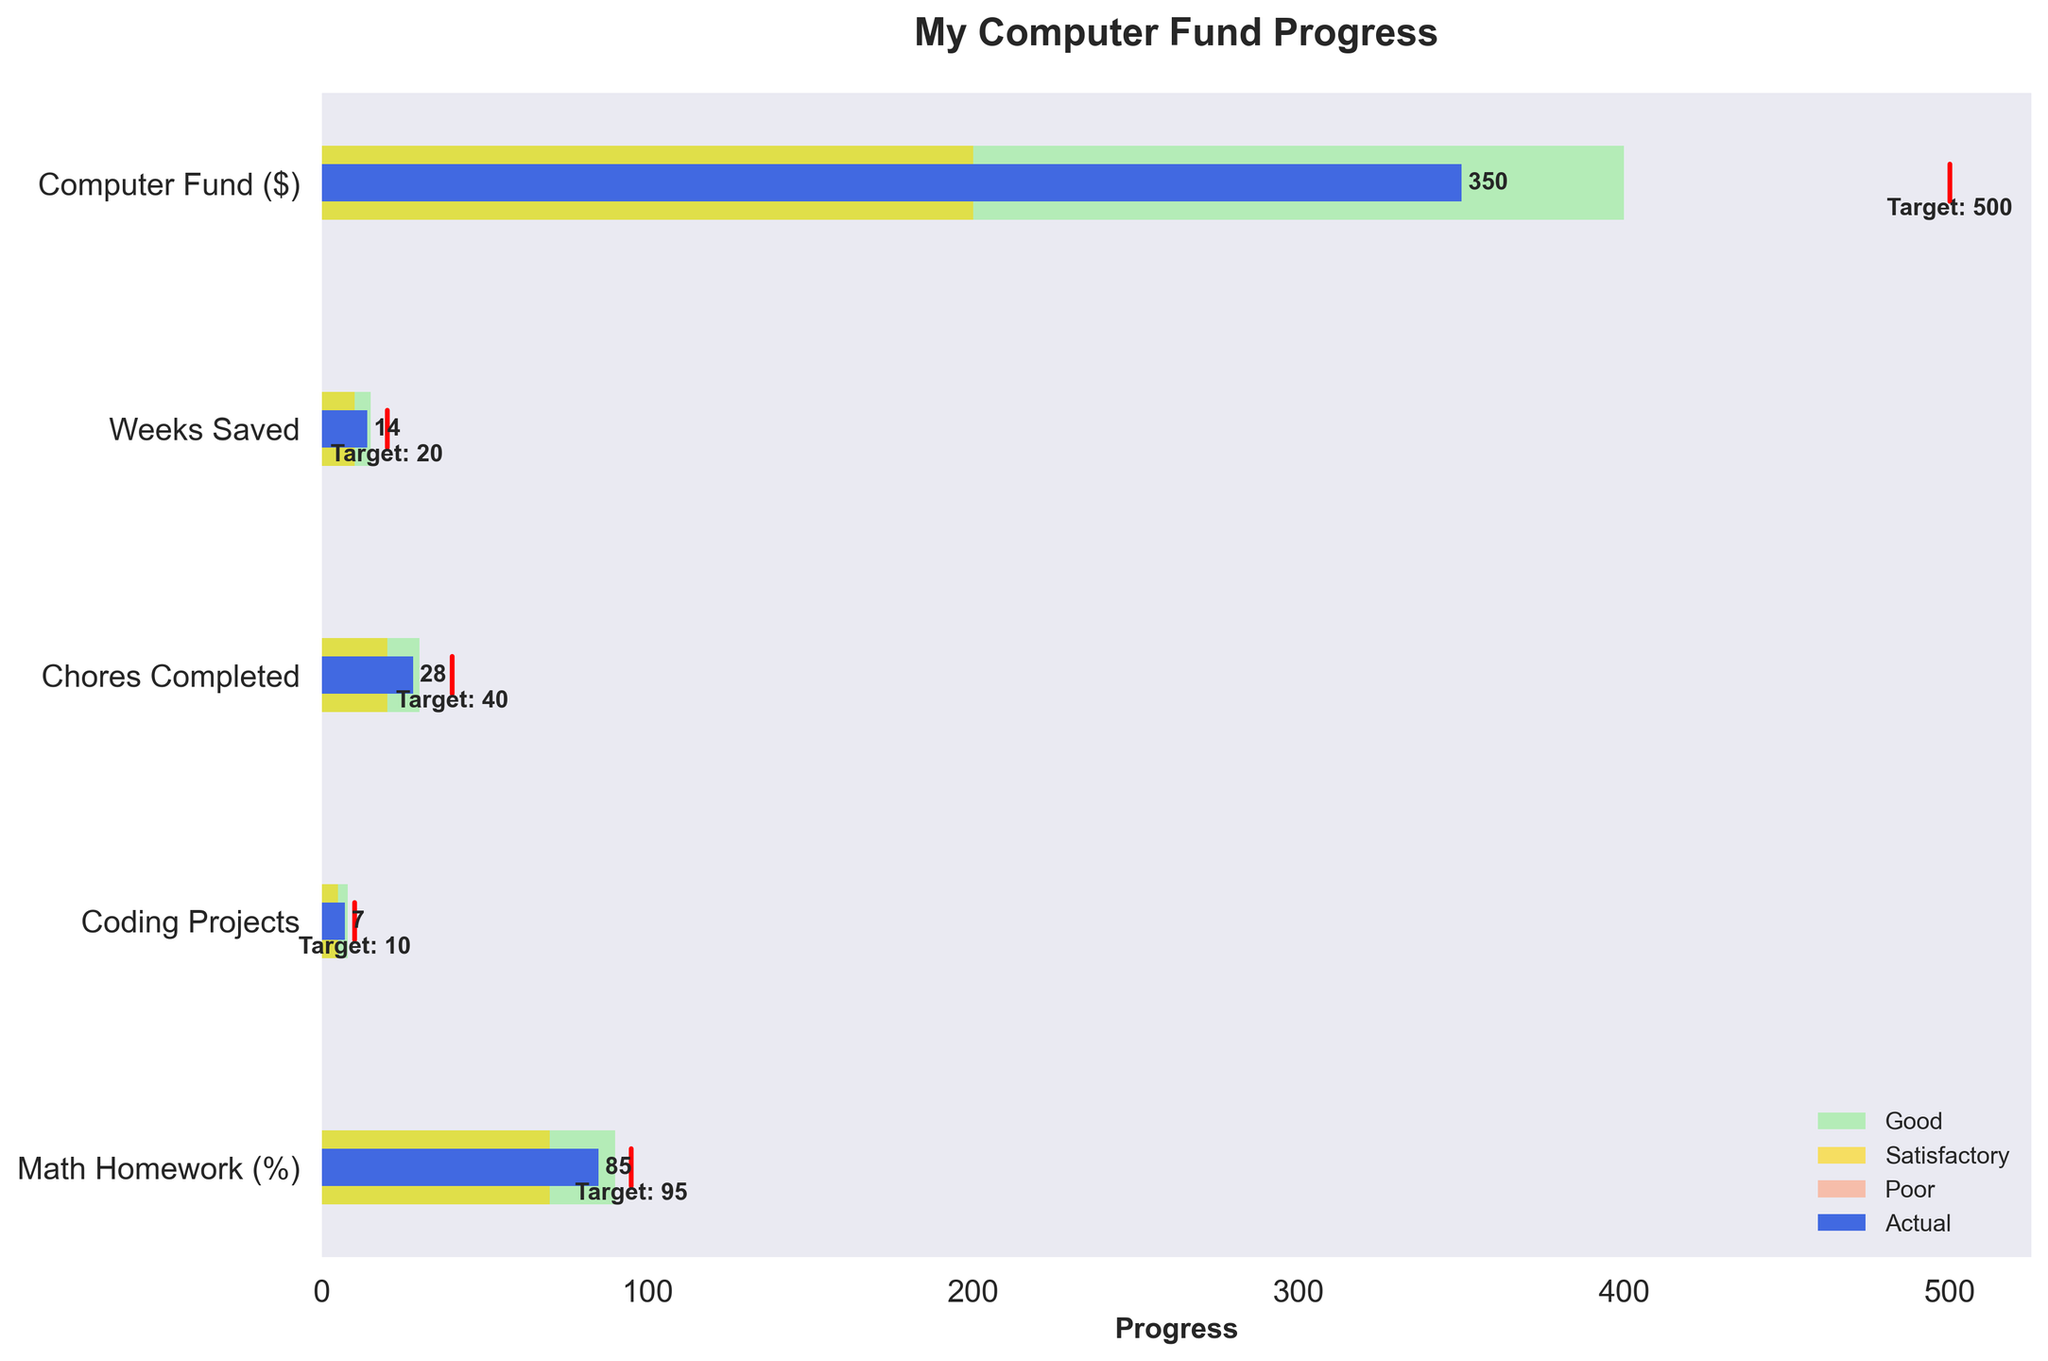How many categories are shown in the chart? To determine the number of categories, count the number of unique titles listed on the y-axis. These titles correspond to the different aspects of savings and progress the chart is tracking.
Answer: 5 What is the target amount for the "Computer Fund ($)" category? Look at the label "Target: 500" next to the red target line associated with the "Computer Fund ($)" row. This indicates the target amount for that category.
Answer: 500 Is the "Coding Projects" category in the Good range? Compare the actual value of the "Coding Projects" category (7) to the ranges defined by Poor, Satisfactory, and Good. Since 7 is between 5 and 8, it falls under the Satisfactory range.
Answer: No What is the difference between the target and actual weeks saved? To find the difference, subtract the actual value (14) from the target value (20) in the "Weeks Saved" row. 20 - 14 equals 6.
Answer: 6 Which category has the smallest gap between actual and target values? Calculate the difference between actual and target values for each category. The smallest difference is for "Coding Projects" (10 - 7 = 3).
Answer: Coding Projects How many more chores need to be completed to meet the target? Subtract the actual number of chores completed (28) from the target number (40). 40 - 28 equals 12.
Answer: 12 What percentage has been achieved for Math Homework? Divide the actual percentage achieved (85%) by the target (95%) and then multiply by 100 to get the percentage of the goal completed. (85/95) * 100 equals approximately 89.5%.
Answer: 89.5% In which range does the "Weeks Saved" category fall? Compare the actual value (14) of "Weeks Saved" to the ranges defined: Poor (0-10), Satisfactory (10-15), Good (15+). Since 14 is between 10 and 15, it falls under the Satisfactory range.
Answer: Satisfactory How many total categories are in the Good range? Count the categories where the actual value falls within the range labeled as Good. Only "Math Homework (%)" with an actual of 85 falls within the Good range of 70-90.
Answer: 1 